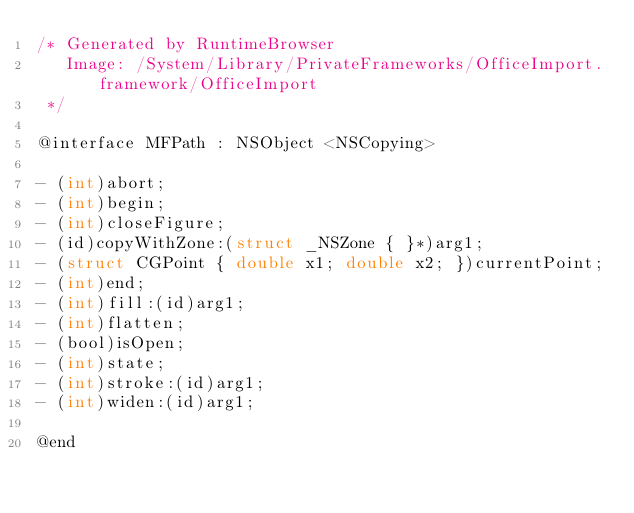Convert code to text. <code><loc_0><loc_0><loc_500><loc_500><_C_>/* Generated by RuntimeBrowser
   Image: /System/Library/PrivateFrameworks/OfficeImport.framework/OfficeImport
 */

@interface MFPath : NSObject <NSCopying>

- (int)abort;
- (int)begin;
- (int)closeFigure;
- (id)copyWithZone:(struct _NSZone { }*)arg1;
- (struct CGPoint { double x1; double x2; })currentPoint;
- (int)end;
- (int)fill:(id)arg1;
- (int)flatten;
- (bool)isOpen;
- (int)state;
- (int)stroke:(id)arg1;
- (int)widen:(id)arg1;

@end
</code> 